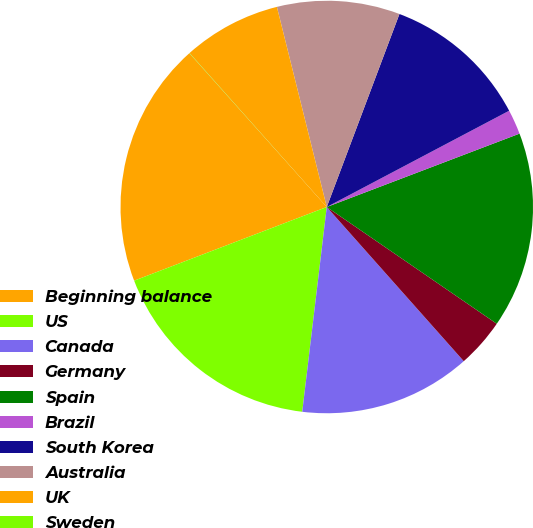Convert chart. <chart><loc_0><loc_0><loc_500><loc_500><pie_chart><fcel>Beginning balance<fcel>US<fcel>Canada<fcel>Germany<fcel>Spain<fcel>Brazil<fcel>South Korea<fcel>Australia<fcel>UK<fcel>Sweden<nl><fcel>19.21%<fcel>17.29%<fcel>13.46%<fcel>3.86%<fcel>15.37%<fcel>1.94%<fcel>11.54%<fcel>9.62%<fcel>7.7%<fcel>0.02%<nl></chart> 